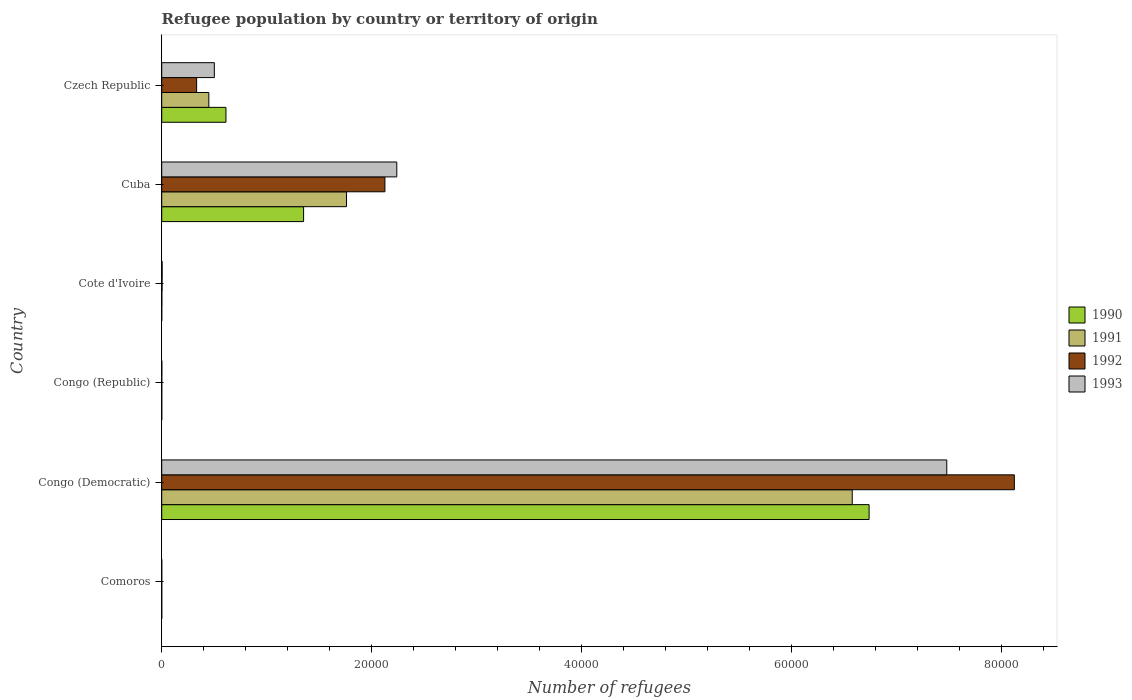How many groups of bars are there?
Offer a very short reply. 6. How many bars are there on the 5th tick from the bottom?
Keep it short and to the point. 4. What is the label of the 6th group of bars from the top?
Make the answer very short. Comoros. Across all countries, what is the maximum number of refugees in 1991?
Offer a very short reply. 6.58e+04. Across all countries, what is the minimum number of refugees in 1990?
Provide a short and direct response. 2. In which country was the number of refugees in 1992 maximum?
Ensure brevity in your answer.  Congo (Democratic). In which country was the number of refugees in 1992 minimum?
Your response must be concise. Comoros. What is the total number of refugees in 1991 in the graph?
Ensure brevity in your answer.  8.79e+04. What is the difference between the number of refugees in 1990 in Congo (Republic) and the number of refugees in 1991 in Cote d'Ivoire?
Keep it short and to the point. -11. What is the average number of refugees in 1991 per country?
Offer a terse response. 1.47e+04. In how many countries, is the number of refugees in 1991 greater than 32000 ?
Offer a very short reply. 1. What is the ratio of the number of refugees in 1993 in Cote d'Ivoire to that in Cuba?
Provide a short and direct response. 0. Is the difference between the number of refugees in 1993 in Congo (Republic) and Cote d'Ivoire greater than the difference between the number of refugees in 1992 in Congo (Republic) and Cote d'Ivoire?
Ensure brevity in your answer.  No. What is the difference between the highest and the second highest number of refugees in 1993?
Offer a very short reply. 5.24e+04. What is the difference between the highest and the lowest number of refugees in 1991?
Provide a short and direct response. 6.58e+04. What does the 3rd bar from the top in Comoros represents?
Provide a short and direct response. 1991. How many bars are there?
Keep it short and to the point. 24. Does the graph contain any zero values?
Give a very brief answer. No. How are the legend labels stacked?
Provide a short and direct response. Vertical. What is the title of the graph?
Offer a very short reply. Refugee population by country or territory of origin. Does "1975" appear as one of the legend labels in the graph?
Offer a very short reply. No. What is the label or title of the X-axis?
Make the answer very short. Number of refugees. What is the label or title of the Y-axis?
Your answer should be compact. Country. What is the Number of refugees of 1991 in Comoros?
Offer a very short reply. 2. What is the Number of refugees in 1992 in Comoros?
Offer a very short reply. 2. What is the Number of refugees of 1993 in Comoros?
Your response must be concise. 2. What is the Number of refugees in 1990 in Congo (Democratic)?
Ensure brevity in your answer.  6.74e+04. What is the Number of refugees in 1991 in Congo (Democratic)?
Make the answer very short. 6.58e+04. What is the Number of refugees of 1992 in Congo (Democratic)?
Ensure brevity in your answer.  8.13e+04. What is the Number of refugees in 1993 in Congo (Democratic)?
Keep it short and to the point. 7.48e+04. What is the Number of refugees of 1991 in Congo (Republic)?
Your answer should be very brief. 4. What is the Number of refugees of 1992 in Congo (Republic)?
Keep it short and to the point. 7. What is the Number of refugees in 1990 in Cote d'Ivoire?
Give a very brief answer. 2. What is the Number of refugees in 1991 in Cote d'Ivoire?
Your response must be concise. 13. What is the Number of refugees in 1992 in Cote d'Ivoire?
Ensure brevity in your answer.  34. What is the Number of refugees of 1990 in Cuba?
Your response must be concise. 1.35e+04. What is the Number of refugees of 1991 in Cuba?
Provide a succinct answer. 1.76e+04. What is the Number of refugees of 1992 in Cuba?
Keep it short and to the point. 2.13e+04. What is the Number of refugees in 1993 in Cuba?
Your answer should be compact. 2.24e+04. What is the Number of refugees of 1990 in Czech Republic?
Your answer should be compact. 6123. What is the Number of refugees of 1991 in Czech Republic?
Your answer should be compact. 4491. What is the Number of refugees in 1992 in Czech Republic?
Offer a very short reply. 3327. What is the Number of refugees of 1993 in Czech Republic?
Provide a short and direct response. 5015. Across all countries, what is the maximum Number of refugees in 1990?
Keep it short and to the point. 6.74e+04. Across all countries, what is the maximum Number of refugees of 1991?
Your response must be concise. 6.58e+04. Across all countries, what is the maximum Number of refugees in 1992?
Provide a short and direct response. 8.13e+04. Across all countries, what is the maximum Number of refugees in 1993?
Offer a terse response. 7.48e+04. Across all countries, what is the minimum Number of refugees of 1993?
Provide a succinct answer. 2. What is the total Number of refugees in 1990 in the graph?
Your answer should be very brief. 8.71e+04. What is the total Number of refugees of 1991 in the graph?
Provide a short and direct response. 8.79e+04. What is the total Number of refugees of 1992 in the graph?
Your response must be concise. 1.06e+05. What is the total Number of refugees of 1993 in the graph?
Your answer should be very brief. 1.02e+05. What is the difference between the Number of refugees in 1990 in Comoros and that in Congo (Democratic)?
Offer a terse response. -6.74e+04. What is the difference between the Number of refugees of 1991 in Comoros and that in Congo (Democratic)?
Ensure brevity in your answer.  -6.58e+04. What is the difference between the Number of refugees in 1992 in Comoros and that in Congo (Democratic)?
Provide a short and direct response. -8.13e+04. What is the difference between the Number of refugees in 1993 in Comoros and that in Congo (Democratic)?
Offer a terse response. -7.48e+04. What is the difference between the Number of refugees in 1991 in Comoros and that in Congo (Republic)?
Keep it short and to the point. -2. What is the difference between the Number of refugees of 1990 in Comoros and that in Cote d'Ivoire?
Keep it short and to the point. 2. What is the difference between the Number of refugees of 1991 in Comoros and that in Cote d'Ivoire?
Offer a very short reply. -11. What is the difference between the Number of refugees of 1992 in Comoros and that in Cote d'Ivoire?
Keep it short and to the point. -32. What is the difference between the Number of refugees of 1993 in Comoros and that in Cote d'Ivoire?
Give a very brief answer. -39. What is the difference between the Number of refugees of 1990 in Comoros and that in Cuba?
Ensure brevity in your answer.  -1.35e+04. What is the difference between the Number of refugees of 1991 in Comoros and that in Cuba?
Provide a short and direct response. -1.76e+04. What is the difference between the Number of refugees in 1992 in Comoros and that in Cuba?
Keep it short and to the point. -2.13e+04. What is the difference between the Number of refugees of 1993 in Comoros and that in Cuba?
Your answer should be very brief. -2.24e+04. What is the difference between the Number of refugees in 1990 in Comoros and that in Czech Republic?
Your answer should be very brief. -6119. What is the difference between the Number of refugees of 1991 in Comoros and that in Czech Republic?
Ensure brevity in your answer.  -4489. What is the difference between the Number of refugees in 1992 in Comoros and that in Czech Republic?
Your answer should be very brief. -3325. What is the difference between the Number of refugees in 1993 in Comoros and that in Czech Republic?
Give a very brief answer. -5013. What is the difference between the Number of refugees of 1990 in Congo (Democratic) and that in Congo (Republic)?
Give a very brief answer. 6.74e+04. What is the difference between the Number of refugees of 1991 in Congo (Democratic) and that in Congo (Republic)?
Provide a short and direct response. 6.58e+04. What is the difference between the Number of refugees of 1992 in Congo (Democratic) and that in Congo (Republic)?
Ensure brevity in your answer.  8.13e+04. What is the difference between the Number of refugees in 1993 in Congo (Democratic) and that in Congo (Republic)?
Your answer should be compact. 7.48e+04. What is the difference between the Number of refugees of 1990 in Congo (Democratic) and that in Cote d'Ivoire?
Provide a succinct answer. 6.74e+04. What is the difference between the Number of refugees of 1991 in Congo (Democratic) and that in Cote d'Ivoire?
Your answer should be compact. 6.58e+04. What is the difference between the Number of refugees of 1992 in Congo (Democratic) and that in Cote d'Ivoire?
Make the answer very short. 8.12e+04. What is the difference between the Number of refugees of 1993 in Congo (Democratic) and that in Cote d'Ivoire?
Offer a terse response. 7.48e+04. What is the difference between the Number of refugees in 1990 in Congo (Democratic) and that in Cuba?
Make the answer very short. 5.39e+04. What is the difference between the Number of refugees of 1991 in Congo (Democratic) and that in Cuba?
Keep it short and to the point. 4.82e+04. What is the difference between the Number of refugees in 1992 in Congo (Democratic) and that in Cuba?
Your answer should be very brief. 6.00e+04. What is the difference between the Number of refugees in 1993 in Congo (Democratic) and that in Cuba?
Give a very brief answer. 5.24e+04. What is the difference between the Number of refugees of 1990 in Congo (Democratic) and that in Czech Republic?
Ensure brevity in your answer.  6.13e+04. What is the difference between the Number of refugees of 1991 in Congo (Democratic) and that in Czech Republic?
Give a very brief answer. 6.13e+04. What is the difference between the Number of refugees in 1992 in Congo (Democratic) and that in Czech Republic?
Provide a succinct answer. 7.79e+04. What is the difference between the Number of refugees in 1993 in Congo (Democratic) and that in Czech Republic?
Offer a very short reply. 6.98e+04. What is the difference between the Number of refugees in 1991 in Congo (Republic) and that in Cote d'Ivoire?
Offer a very short reply. -9. What is the difference between the Number of refugees of 1992 in Congo (Republic) and that in Cote d'Ivoire?
Your response must be concise. -27. What is the difference between the Number of refugees in 1993 in Congo (Republic) and that in Cote d'Ivoire?
Offer a terse response. -30. What is the difference between the Number of refugees of 1990 in Congo (Republic) and that in Cuba?
Ensure brevity in your answer.  -1.35e+04. What is the difference between the Number of refugees in 1991 in Congo (Republic) and that in Cuba?
Offer a very short reply. -1.76e+04. What is the difference between the Number of refugees in 1992 in Congo (Republic) and that in Cuba?
Provide a short and direct response. -2.13e+04. What is the difference between the Number of refugees in 1993 in Congo (Republic) and that in Cuba?
Your answer should be compact. -2.24e+04. What is the difference between the Number of refugees in 1990 in Congo (Republic) and that in Czech Republic?
Your response must be concise. -6121. What is the difference between the Number of refugees in 1991 in Congo (Republic) and that in Czech Republic?
Make the answer very short. -4487. What is the difference between the Number of refugees of 1992 in Congo (Republic) and that in Czech Republic?
Provide a short and direct response. -3320. What is the difference between the Number of refugees of 1993 in Congo (Republic) and that in Czech Republic?
Give a very brief answer. -5004. What is the difference between the Number of refugees in 1990 in Cote d'Ivoire and that in Cuba?
Offer a terse response. -1.35e+04. What is the difference between the Number of refugees of 1991 in Cote d'Ivoire and that in Cuba?
Your answer should be compact. -1.76e+04. What is the difference between the Number of refugees of 1992 in Cote d'Ivoire and that in Cuba?
Your response must be concise. -2.12e+04. What is the difference between the Number of refugees in 1993 in Cote d'Ivoire and that in Cuba?
Your answer should be very brief. -2.24e+04. What is the difference between the Number of refugees of 1990 in Cote d'Ivoire and that in Czech Republic?
Make the answer very short. -6121. What is the difference between the Number of refugees in 1991 in Cote d'Ivoire and that in Czech Republic?
Make the answer very short. -4478. What is the difference between the Number of refugees in 1992 in Cote d'Ivoire and that in Czech Republic?
Provide a succinct answer. -3293. What is the difference between the Number of refugees in 1993 in Cote d'Ivoire and that in Czech Republic?
Offer a very short reply. -4974. What is the difference between the Number of refugees of 1990 in Cuba and that in Czech Republic?
Your answer should be compact. 7400. What is the difference between the Number of refugees of 1991 in Cuba and that in Czech Republic?
Provide a short and direct response. 1.31e+04. What is the difference between the Number of refugees in 1992 in Cuba and that in Czech Republic?
Your answer should be very brief. 1.79e+04. What is the difference between the Number of refugees of 1993 in Cuba and that in Czech Republic?
Your answer should be very brief. 1.74e+04. What is the difference between the Number of refugees in 1990 in Comoros and the Number of refugees in 1991 in Congo (Democratic)?
Your answer should be compact. -6.58e+04. What is the difference between the Number of refugees of 1990 in Comoros and the Number of refugees of 1992 in Congo (Democratic)?
Offer a terse response. -8.13e+04. What is the difference between the Number of refugees of 1990 in Comoros and the Number of refugees of 1993 in Congo (Democratic)?
Your response must be concise. -7.48e+04. What is the difference between the Number of refugees of 1991 in Comoros and the Number of refugees of 1992 in Congo (Democratic)?
Keep it short and to the point. -8.13e+04. What is the difference between the Number of refugees in 1991 in Comoros and the Number of refugees in 1993 in Congo (Democratic)?
Provide a succinct answer. -7.48e+04. What is the difference between the Number of refugees of 1992 in Comoros and the Number of refugees of 1993 in Congo (Democratic)?
Give a very brief answer. -7.48e+04. What is the difference between the Number of refugees in 1990 in Comoros and the Number of refugees in 1993 in Congo (Republic)?
Your answer should be very brief. -7. What is the difference between the Number of refugees of 1992 in Comoros and the Number of refugees of 1993 in Congo (Republic)?
Your answer should be compact. -9. What is the difference between the Number of refugees in 1990 in Comoros and the Number of refugees in 1991 in Cote d'Ivoire?
Provide a succinct answer. -9. What is the difference between the Number of refugees of 1990 in Comoros and the Number of refugees of 1992 in Cote d'Ivoire?
Make the answer very short. -30. What is the difference between the Number of refugees in 1990 in Comoros and the Number of refugees in 1993 in Cote d'Ivoire?
Ensure brevity in your answer.  -37. What is the difference between the Number of refugees in 1991 in Comoros and the Number of refugees in 1992 in Cote d'Ivoire?
Give a very brief answer. -32. What is the difference between the Number of refugees in 1991 in Comoros and the Number of refugees in 1993 in Cote d'Ivoire?
Give a very brief answer. -39. What is the difference between the Number of refugees in 1992 in Comoros and the Number of refugees in 1993 in Cote d'Ivoire?
Make the answer very short. -39. What is the difference between the Number of refugees in 1990 in Comoros and the Number of refugees in 1991 in Cuba?
Make the answer very short. -1.76e+04. What is the difference between the Number of refugees in 1990 in Comoros and the Number of refugees in 1992 in Cuba?
Provide a succinct answer. -2.13e+04. What is the difference between the Number of refugees in 1990 in Comoros and the Number of refugees in 1993 in Cuba?
Your answer should be compact. -2.24e+04. What is the difference between the Number of refugees in 1991 in Comoros and the Number of refugees in 1992 in Cuba?
Provide a short and direct response. -2.13e+04. What is the difference between the Number of refugees in 1991 in Comoros and the Number of refugees in 1993 in Cuba?
Keep it short and to the point. -2.24e+04. What is the difference between the Number of refugees in 1992 in Comoros and the Number of refugees in 1993 in Cuba?
Keep it short and to the point. -2.24e+04. What is the difference between the Number of refugees of 1990 in Comoros and the Number of refugees of 1991 in Czech Republic?
Provide a succinct answer. -4487. What is the difference between the Number of refugees in 1990 in Comoros and the Number of refugees in 1992 in Czech Republic?
Provide a short and direct response. -3323. What is the difference between the Number of refugees of 1990 in Comoros and the Number of refugees of 1993 in Czech Republic?
Your answer should be compact. -5011. What is the difference between the Number of refugees of 1991 in Comoros and the Number of refugees of 1992 in Czech Republic?
Ensure brevity in your answer.  -3325. What is the difference between the Number of refugees of 1991 in Comoros and the Number of refugees of 1993 in Czech Republic?
Give a very brief answer. -5013. What is the difference between the Number of refugees in 1992 in Comoros and the Number of refugees in 1993 in Czech Republic?
Keep it short and to the point. -5013. What is the difference between the Number of refugees in 1990 in Congo (Democratic) and the Number of refugees in 1991 in Congo (Republic)?
Offer a terse response. 6.74e+04. What is the difference between the Number of refugees in 1990 in Congo (Democratic) and the Number of refugees in 1992 in Congo (Republic)?
Provide a short and direct response. 6.74e+04. What is the difference between the Number of refugees in 1990 in Congo (Democratic) and the Number of refugees in 1993 in Congo (Republic)?
Offer a very short reply. 6.74e+04. What is the difference between the Number of refugees in 1991 in Congo (Democratic) and the Number of refugees in 1992 in Congo (Republic)?
Provide a short and direct response. 6.58e+04. What is the difference between the Number of refugees of 1991 in Congo (Democratic) and the Number of refugees of 1993 in Congo (Republic)?
Your response must be concise. 6.58e+04. What is the difference between the Number of refugees in 1992 in Congo (Democratic) and the Number of refugees in 1993 in Congo (Republic)?
Give a very brief answer. 8.13e+04. What is the difference between the Number of refugees of 1990 in Congo (Democratic) and the Number of refugees of 1991 in Cote d'Ivoire?
Make the answer very short. 6.74e+04. What is the difference between the Number of refugees of 1990 in Congo (Democratic) and the Number of refugees of 1992 in Cote d'Ivoire?
Provide a short and direct response. 6.74e+04. What is the difference between the Number of refugees in 1990 in Congo (Democratic) and the Number of refugees in 1993 in Cote d'Ivoire?
Your response must be concise. 6.74e+04. What is the difference between the Number of refugees of 1991 in Congo (Democratic) and the Number of refugees of 1992 in Cote d'Ivoire?
Ensure brevity in your answer.  6.58e+04. What is the difference between the Number of refugees in 1991 in Congo (Democratic) and the Number of refugees in 1993 in Cote d'Ivoire?
Your answer should be very brief. 6.58e+04. What is the difference between the Number of refugees of 1992 in Congo (Democratic) and the Number of refugees of 1993 in Cote d'Ivoire?
Your answer should be compact. 8.12e+04. What is the difference between the Number of refugees of 1990 in Congo (Democratic) and the Number of refugees of 1991 in Cuba?
Provide a short and direct response. 4.98e+04. What is the difference between the Number of refugees in 1990 in Congo (Democratic) and the Number of refugees in 1992 in Cuba?
Your answer should be compact. 4.62e+04. What is the difference between the Number of refugees of 1990 in Congo (Democratic) and the Number of refugees of 1993 in Cuba?
Provide a succinct answer. 4.50e+04. What is the difference between the Number of refugees in 1991 in Congo (Democratic) and the Number of refugees in 1992 in Cuba?
Give a very brief answer. 4.45e+04. What is the difference between the Number of refugees of 1991 in Congo (Democratic) and the Number of refugees of 1993 in Cuba?
Your response must be concise. 4.34e+04. What is the difference between the Number of refugees in 1992 in Congo (Democratic) and the Number of refugees in 1993 in Cuba?
Provide a succinct answer. 5.89e+04. What is the difference between the Number of refugees of 1990 in Congo (Democratic) and the Number of refugees of 1991 in Czech Republic?
Provide a short and direct response. 6.29e+04. What is the difference between the Number of refugees in 1990 in Congo (Democratic) and the Number of refugees in 1992 in Czech Republic?
Make the answer very short. 6.41e+04. What is the difference between the Number of refugees in 1990 in Congo (Democratic) and the Number of refugees in 1993 in Czech Republic?
Provide a succinct answer. 6.24e+04. What is the difference between the Number of refugees in 1991 in Congo (Democratic) and the Number of refugees in 1992 in Czech Republic?
Your response must be concise. 6.25e+04. What is the difference between the Number of refugees of 1991 in Congo (Democratic) and the Number of refugees of 1993 in Czech Republic?
Provide a succinct answer. 6.08e+04. What is the difference between the Number of refugees of 1992 in Congo (Democratic) and the Number of refugees of 1993 in Czech Republic?
Make the answer very short. 7.63e+04. What is the difference between the Number of refugees of 1990 in Congo (Republic) and the Number of refugees of 1992 in Cote d'Ivoire?
Your response must be concise. -32. What is the difference between the Number of refugees in 1990 in Congo (Republic) and the Number of refugees in 1993 in Cote d'Ivoire?
Make the answer very short. -39. What is the difference between the Number of refugees of 1991 in Congo (Republic) and the Number of refugees of 1992 in Cote d'Ivoire?
Offer a very short reply. -30. What is the difference between the Number of refugees of 1991 in Congo (Republic) and the Number of refugees of 1993 in Cote d'Ivoire?
Make the answer very short. -37. What is the difference between the Number of refugees of 1992 in Congo (Republic) and the Number of refugees of 1993 in Cote d'Ivoire?
Your response must be concise. -34. What is the difference between the Number of refugees in 1990 in Congo (Republic) and the Number of refugees in 1991 in Cuba?
Ensure brevity in your answer.  -1.76e+04. What is the difference between the Number of refugees of 1990 in Congo (Republic) and the Number of refugees of 1992 in Cuba?
Ensure brevity in your answer.  -2.13e+04. What is the difference between the Number of refugees in 1990 in Congo (Republic) and the Number of refugees in 1993 in Cuba?
Your answer should be compact. -2.24e+04. What is the difference between the Number of refugees of 1991 in Congo (Republic) and the Number of refugees of 1992 in Cuba?
Give a very brief answer. -2.13e+04. What is the difference between the Number of refugees in 1991 in Congo (Republic) and the Number of refugees in 1993 in Cuba?
Your response must be concise. -2.24e+04. What is the difference between the Number of refugees in 1992 in Congo (Republic) and the Number of refugees in 1993 in Cuba?
Keep it short and to the point. -2.24e+04. What is the difference between the Number of refugees in 1990 in Congo (Republic) and the Number of refugees in 1991 in Czech Republic?
Your answer should be very brief. -4489. What is the difference between the Number of refugees of 1990 in Congo (Republic) and the Number of refugees of 1992 in Czech Republic?
Your answer should be compact. -3325. What is the difference between the Number of refugees of 1990 in Congo (Republic) and the Number of refugees of 1993 in Czech Republic?
Give a very brief answer. -5013. What is the difference between the Number of refugees of 1991 in Congo (Republic) and the Number of refugees of 1992 in Czech Republic?
Your answer should be compact. -3323. What is the difference between the Number of refugees in 1991 in Congo (Republic) and the Number of refugees in 1993 in Czech Republic?
Ensure brevity in your answer.  -5011. What is the difference between the Number of refugees of 1992 in Congo (Republic) and the Number of refugees of 1993 in Czech Republic?
Provide a short and direct response. -5008. What is the difference between the Number of refugees in 1990 in Cote d'Ivoire and the Number of refugees in 1991 in Cuba?
Offer a terse response. -1.76e+04. What is the difference between the Number of refugees in 1990 in Cote d'Ivoire and the Number of refugees in 1992 in Cuba?
Your response must be concise. -2.13e+04. What is the difference between the Number of refugees of 1990 in Cote d'Ivoire and the Number of refugees of 1993 in Cuba?
Your response must be concise. -2.24e+04. What is the difference between the Number of refugees of 1991 in Cote d'Ivoire and the Number of refugees of 1992 in Cuba?
Keep it short and to the point. -2.13e+04. What is the difference between the Number of refugees of 1991 in Cote d'Ivoire and the Number of refugees of 1993 in Cuba?
Your response must be concise. -2.24e+04. What is the difference between the Number of refugees in 1992 in Cote d'Ivoire and the Number of refugees in 1993 in Cuba?
Your response must be concise. -2.24e+04. What is the difference between the Number of refugees of 1990 in Cote d'Ivoire and the Number of refugees of 1991 in Czech Republic?
Offer a terse response. -4489. What is the difference between the Number of refugees in 1990 in Cote d'Ivoire and the Number of refugees in 1992 in Czech Republic?
Offer a terse response. -3325. What is the difference between the Number of refugees in 1990 in Cote d'Ivoire and the Number of refugees in 1993 in Czech Republic?
Provide a succinct answer. -5013. What is the difference between the Number of refugees of 1991 in Cote d'Ivoire and the Number of refugees of 1992 in Czech Republic?
Your answer should be very brief. -3314. What is the difference between the Number of refugees of 1991 in Cote d'Ivoire and the Number of refugees of 1993 in Czech Republic?
Your answer should be very brief. -5002. What is the difference between the Number of refugees of 1992 in Cote d'Ivoire and the Number of refugees of 1993 in Czech Republic?
Provide a short and direct response. -4981. What is the difference between the Number of refugees of 1990 in Cuba and the Number of refugees of 1991 in Czech Republic?
Make the answer very short. 9032. What is the difference between the Number of refugees of 1990 in Cuba and the Number of refugees of 1992 in Czech Republic?
Keep it short and to the point. 1.02e+04. What is the difference between the Number of refugees of 1990 in Cuba and the Number of refugees of 1993 in Czech Republic?
Provide a succinct answer. 8508. What is the difference between the Number of refugees in 1991 in Cuba and the Number of refugees in 1992 in Czech Republic?
Offer a terse response. 1.43e+04. What is the difference between the Number of refugees in 1991 in Cuba and the Number of refugees in 1993 in Czech Republic?
Keep it short and to the point. 1.26e+04. What is the difference between the Number of refugees of 1992 in Cuba and the Number of refugees of 1993 in Czech Republic?
Give a very brief answer. 1.63e+04. What is the average Number of refugees of 1990 per country?
Your answer should be compact. 1.45e+04. What is the average Number of refugees in 1991 per country?
Offer a terse response. 1.47e+04. What is the average Number of refugees in 1992 per country?
Make the answer very short. 1.77e+04. What is the average Number of refugees of 1993 per country?
Offer a terse response. 1.71e+04. What is the difference between the Number of refugees in 1990 and Number of refugees in 1991 in Comoros?
Your answer should be very brief. 2. What is the difference between the Number of refugees of 1990 and Number of refugees of 1992 in Comoros?
Give a very brief answer. 2. What is the difference between the Number of refugees in 1990 and Number of refugees in 1993 in Comoros?
Provide a short and direct response. 2. What is the difference between the Number of refugees of 1991 and Number of refugees of 1993 in Comoros?
Make the answer very short. 0. What is the difference between the Number of refugees of 1992 and Number of refugees of 1993 in Comoros?
Provide a succinct answer. 0. What is the difference between the Number of refugees in 1990 and Number of refugees in 1991 in Congo (Democratic)?
Make the answer very short. 1607. What is the difference between the Number of refugees in 1990 and Number of refugees in 1992 in Congo (Democratic)?
Your answer should be very brief. -1.38e+04. What is the difference between the Number of refugees in 1990 and Number of refugees in 1993 in Congo (Democratic)?
Give a very brief answer. -7403. What is the difference between the Number of refugees of 1991 and Number of refugees of 1992 in Congo (Democratic)?
Make the answer very short. -1.55e+04. What is the difference between the Number of refugees in 1991 and Number of refugees in 1993 in Congo (Democratic)?
Offer a very short reply. -9010. What is the difference between the Number of refugees in 1992 and Number of refugees in 1993 in Congo (Democratic)?
Provide a succinct answer. 6443. What is the difference between the Number of refugees in 1991 and Number of refugees in 1992 in Congo (Republic)?
Make the answer very short. -3. What is the difference between the Number of refugees in 1991 and Number of refugees in 1993 in Congo (Republic)?
Make the answer very short. -7. What is the difference between the Number of refugees of 1992 and Number of refugees of 1993 in Congo (Republic)?
Your answer should be compact. -4. What is the difference between the Number of refugees of 1990 and Number of refugees of 1992 in Cote d'Ivoire?
Your answer should be very brief. -32. What is the difference between the Number of refugees in 1990 and Number of refugees in 1993 in Cote d'Ivoire?
Make the answer very short. -39. What is the difference between the Number of refugees of 1991 and Number of refugees of 1992 in Cote d'Ivoire?
Provide a short and direct response. -21. What is the difference between the Number of refugees in 1990 and Number of refugees in 1991 in Cuba?
Offer a terse response. -4092. What is the difference between the Number of refugees in 1990 and Number of refugees in 1992 in Cuba?
Offer a very short reply. -7750. What is the difference between the Number of refugees in 1990 and Number of refugees in 1993 in Cuba?
Keep it short and to the point. -8883. What is the difference between the Number of refugees in 1991 and Number of refugees in 1992 in Cuba?
Your answer should be compact. -3658. What is the difference between the Number of refugees of 1991 and Number of refugees of 1993 in Cuba?
Keep it short and to the point. -4791. What is the difference between the Number of refugees of 1992 and Number of refugees of 1993 in Cuba?
Provide a succinct answer. -1133. What is the difference between the Number of refugees of 1990 and Number of refugees of 1991 in Czech Republic?
Your answer should be very brief. 1632. What is the difference between the Number of refugees of 1990 and Number of refugees of 1992 in Czech Republic?
Keep it short and to the point. 2796. What is the difference between the Number of refugees in 1990 and Number of refugees in 1993 in Czech Republic?
Offer a very short reply. 1108. What is the difference between the Number of refugees of 1991 and Number of refugees of 1992 in Czech Republic?
Ensure brevity in your answer.  1164. What is the difference between the Number of refugees in 1991 and Number of refugees in 1993 in Czech Republic?
Provide a short and direct response. -524. What is the difference between the Number of refugees in 1992 and Number of refugees in 1993 in Czech Republic?
Keep it short and to the point. -1688. What is the ratio of the Number of refugees in 1991 in Comoros to that in Congo (Democratic)?
Give a very brief answer. 0. What is the ratio of the Number of refugees of 1993 in Comoros to that in Congo (Democratic)?
Ensure brevity in your answer.  0. What is the ratio of the Number of refugees in 1992 in Comoros to that in Congo (Republic)?
Ensure brevity in your answer.  0.29. What is the ratio of the Number of refugees of 1993 in Comoros to that in Congo (Republic)?
Offer a very short reply. 0.18. What is the ratio of the Number of refugees of 1990 in Comoros to that in Cote d'Ivoire?
Give a very brief answer. 2. What is the ratio of the Number of refugees in 1991 in Comoros to that in Cote d'Ivoire?
Give a very brief answer. 0.15. What is the ratio of the Number of refugees of 1992 in Comoros to that in Cote d'Ivoire?
Your answer should be compact. 0.06. What is the ratio of the Number of refugees of 1993 in Comoros to that in Cote d'Ivoire?
Your response must be concise. 0.05. What is the ratio of the Number of refugees of 1990 in Comoros to that in Cuba?
Your answer should be very brief. 0. What is the ratio of the Number of refugees of 1991 in Comoros to that in Cuba?
Your response must be concise. 0. What is the ratio of the Number of refugees of 1992 in Comoros to that in Cuba?
Your answer should be very brief. 0. What is the ratio of the Number of refugees of 1993 in Comoros to that in Cuba?
Make the answer very short. 0. What is the ratio of the Number of refugees of 1990 in Comoros to that in Czech Republic?
Make the answer very short. 0. What is the ratio of the Number of refugees in 1991 in Comoros to that in Czech Republic?
Offer a terse response. 0. What is the ratio of the Number of refugees in 1992 in Comoros to that in Czech Republic?
Your answer should be very brief. 0. What is the ratio of the Number of refugees of 1990 in Congo (Democratic) to that in Congo (Republic)?
Offer a very short reply. 3.37e+04. What is the ratio of the Number of refugees of 1991 in Congo (Democratic) to that in Congo (Republic)?
Your response must be concise. 1.65e+04. What is the ratio of the Number of refugees of 1992 in Congo (Democratic) to that in Congo (Republic)?
Give a very brief answer. 1.16e+04. What is the ratio of the Number of refugees of 1993 in Congo (Democratic) to that in Congo (Republic)?
Make the answer very short. 6802.36. What is the ratio of the Number of refugees in 1990 in Congo (Democratic) to that in Cote d'Ivoire?
Your answer should be very brief. 3.37e+04. What is the ratio of the Number of refugees of 1991 in Congo (Democratic) to that in Cote d'Ivoire?
Your answer should be very brief. 5062.77. What is the ratio of the Number of refugees in 1992 in Congo (Democratic) to that in Cote d'Ivoire?
Offer a terse response. 2390.26. What is the ratio of the Number of refugees in 1993 in Congo (Democratic) to that in Cote d'Ivoire?
Ensure brevity in your answer.  1825.02. What is the ratio of the Number of refugees in 1990 in Congo (Democratic) to that in Cuba?
Make the answer very short. 4.99. What is the ratio of the Number of refugees of 1991 in Congo (Democratic) to that in Cuba?
Ensure brevity in your answer.  3.74. What is the ratio of the Number of refugees in 1992 in Congo (Democratic) to that in Cuba?
Offer a very short reply. 3.82. What is the ratio of the Number of refugees of 1993 in Congo (Democratic) to that in Cuba?
Offer a terse response. 3.34. What is the ratio of the Number of refugees in 1990 in Congo (Democratic) to that in Czech Republic?
Offer a very short reply. 11.01. What is the ratio of the Number of refugees of 1991 in Congo (Democratic) to that in Czech Republic?
Offer a terse response. 14.66. What is the ratio of the Number of refugees in 1992 in Congo (Democratic) to that in Czech Republic?
Offer a terse response. 24.43. What is the ratio of the Number of refugees in 1993 in Congo (Democratic) to that in Czech Republic?
Keep it short and to the point. 14.92. What is the ratio of the Number of refugees of 1991 in Congo (Republic) to that in Cote d'Ivoire?
Your response must be concise. 0.31. What is the ratio of the Number of refugees of 1992 in Congo (Republic) to that in Cote d'Ivoire?
Offer a very short reply. 0.21. What is the ratio of the Number of refugees of 1993 in Congo (Republic) to that in Cote d'Ivoire?
Offer a terse response. 0.27. What is the ratio of the Number of refugees in 1991 in Congo (Republic) to that in Cuba?
Ensure brevity in your answer.  0. What is the ratio of the Number of refugees in 1993 in Congo (Republic) to that in Cuba?
Keep it short and to the point. 0. What is the ratio of the Number of refugees in 1990 in Congo (Republic) to that in Czech Republic?
Your response must be concise. 0. What is the ratio of the Number of refugees of 1991 in Congo (Republic) to that in Czech Republic?
Provide a short and direct response. 0. What is the ratio of the Number of refugees in 1992 in Congo (Republic) to that in Czech Republic?
Your answer should be very brief. 0. What is the ratio of the Number of refugees in 1993 in Congo (Republic) to that in Czech Republic?
Keep it short and to the point. 0. What is the ratio of the Number of refugees of 1991 in Cote d'Ivoire to that in Cuba?
Provide a short and direct response. 0. What is the ratio of the Number of refugees of 1992 in Cote d'Ivoire to that in Cuba?
Provide a short and direct response. 0. What is the ratio of the Number of refugees in 1993 in Cote d'Ivoire to that in Cuba?
Offer a very short reply. 0. What is the ratio of the Number of refugees of 1990 in Cote d'Ivoire to that in Czech Republic?
Provide a short and direct response. 0. What is the ratio of the Number of refugees in 1991 in Cote d'Ivoire to that in Czech Republic?
Offer a very short reply. 0. What is the ratio of the Number of refugees of 1992 in Cote d'Ivoire to that in Czech Republic?
Keep it short and to the point. 0.01. What is the ratio of the Number of refugees of 1993 in Cote d'Ivoire to that in Czech Republic?
Keep it short and to the point. 0.01. What is the ratio of the Number of refugees of 1990 in Cuba to that in Czech Republic?
Give a very brief answer. 2.21. What is the ratio of the Number of refugees in 1991 in Cuba to that in Czech Republic?
Keep it short and to the point. 3.92. What is the ratio of the Number of refugees of 1992 in Cuba to that in Czech Republic?
Give a very brief answer. 6.39. What is the ratio of the Number of refugees of 1993 in Cuba to that in Czech Republic?
Give a very brief answer. 4.47. What is the difference between the highest and the second highest Number of refugees in 1990?
Ensure brevity in your answer.  5.39e+04. What is the difference between the highest and the second highest Number of refugees in 1991?
Your answer should be very brief. 4.82e+04. What is the difference between the highest and the second highest Number of refugees of 1992?
Your answer should be very brief. 6.00e+04. What is the difference between the highest and the second highest Number of refugees in 1993?
Make the answer very short. 5.24e+04. What is the difference between the highest and the lowest Number of refugees of 1990?
Keep it short and to the point. 6.74e+04. What is the difference between the highest and the lowest Number of refugees in 1991?
Provide a succinct answer. 6.58e+04. What is the difference between the highest and the lowest Number of refugees in 1992?
Ensure brevity in your answer.  8.13e+04. What is the difference between the highest and the lowest Number of refugees of 1993?
Give a very brief answer. 7.48e+04. 